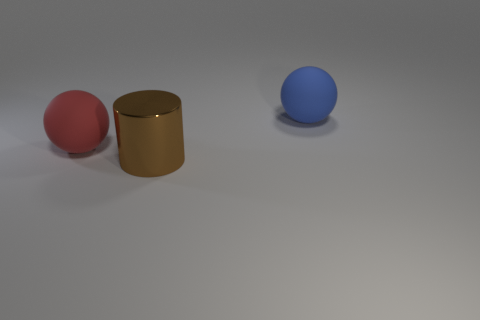How many matte objects are large things or large green cubes?
Give a very brief answer. 2. Does the rubber thing on the left side of the big blue matte object have the same shape as the metal thing that is to the right of the red ball?
Ensure brevity in your answer.  No. How many big brown metallic cylinders are on the right side of the brown object?
Your answer should be very brief. 0. Is there a blue thing made of the same material as the brown thing?
Provide a succinct answer. No. There is a brown cylinder that is the same size as the blue rubber object; what is its material?
Provide a short and direct response. Metal. Does the red sphere have the same material as the big blue ball?
Offer a terse response. Yes. How many objects are either small brown cubes or big balls?
Keep it short and to the point. 2. There is a large rubber object behind the red matte ball; what is its shape?
Give a very brief answer. Sphere. The other big ball that is made of the same material as the blue sphere is what color?
Provide a short and direct response. Red. There is another object that is the same shape as the red thing; what is its material?
Offer a terse response. Rubber. 